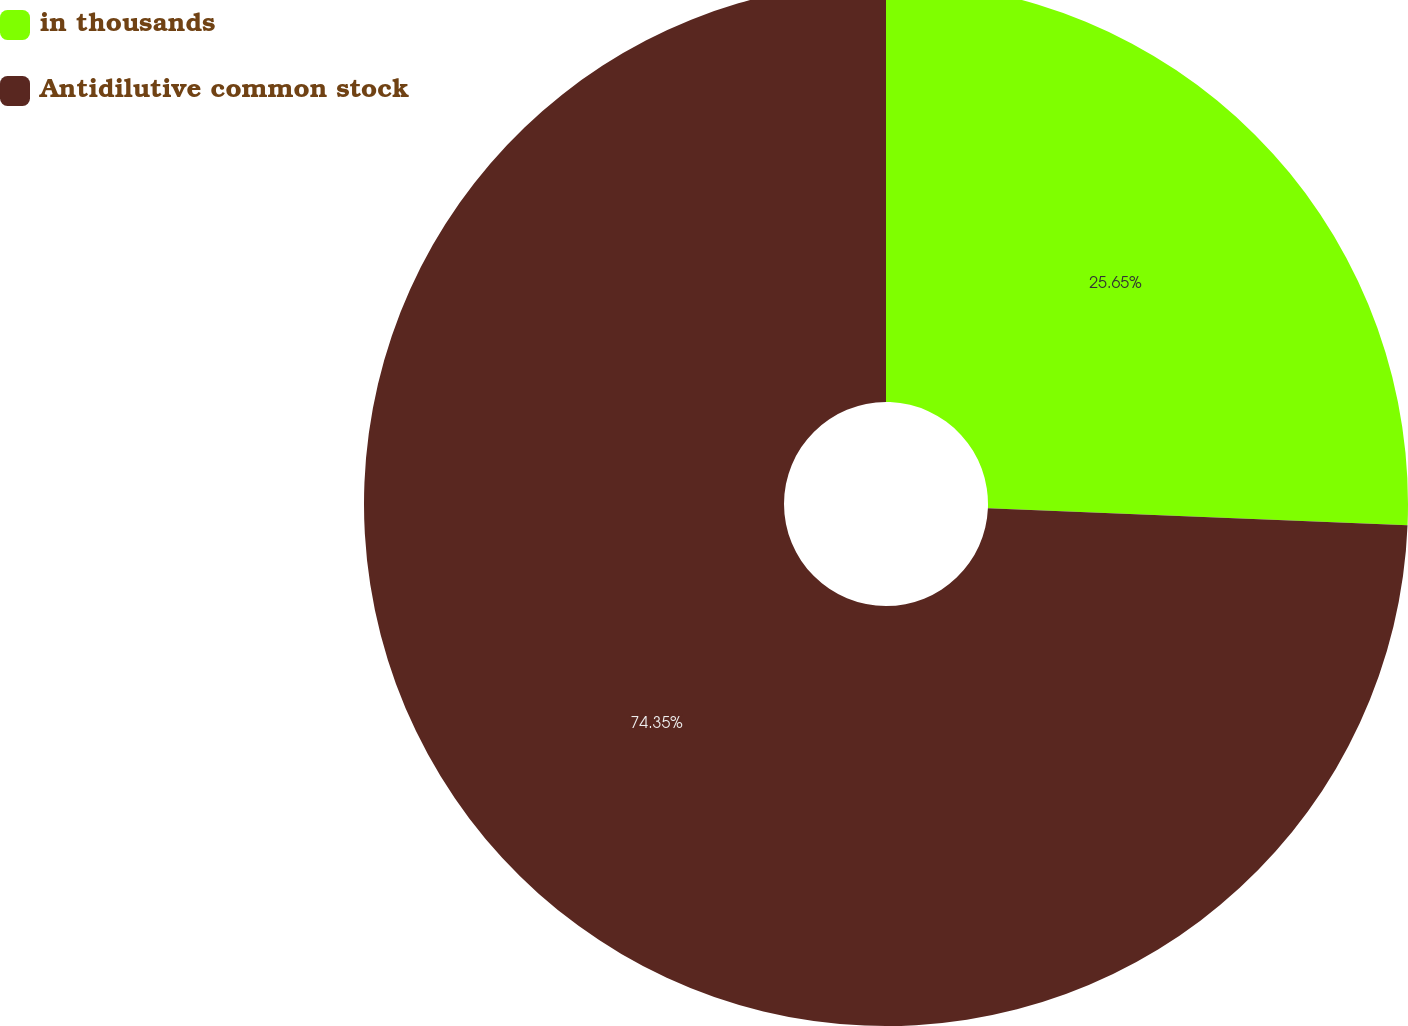<chart> <loc_0><loc_0><loc_500><loc_500><pie_chart><fcel>in thousands<fcel>Antidilutive common stock<nl><fcel>25.65%<fcel>74.35%<nl></chart> 